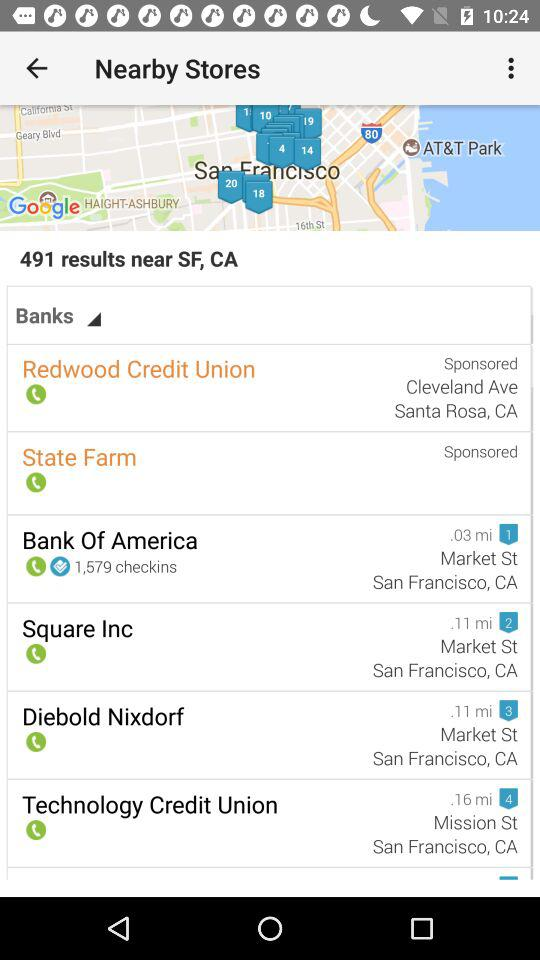Are there any banks listed that serve as technology-focused financial institutions? Yes, the Technology Credit Union appears to be a financial institution with a tech orientation, as suggested by its name and its listing under the search results for banks. Is the Technology Credit Union part of a larger chain, or is it specific to this area? Without more information, I can't confirm the size of its network. Typically, credit unions are community-focused and may have a more localized presence compared to larger banking chains. 